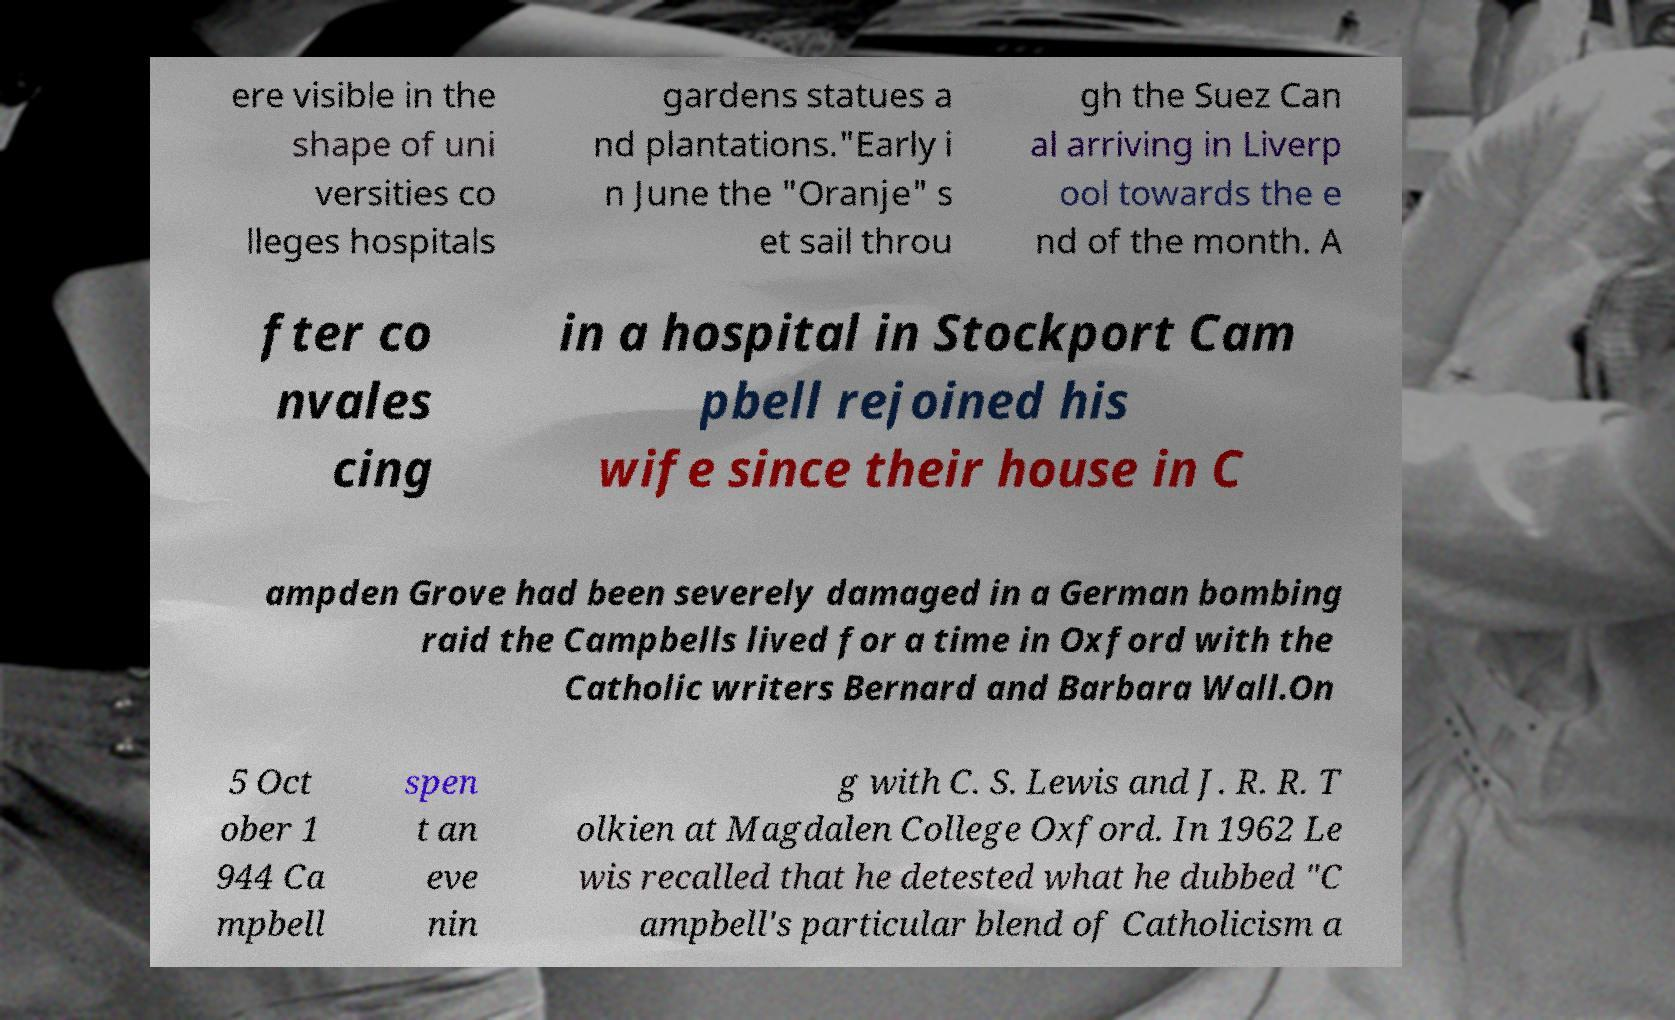Could you assist in decoding the text presented in this image and type it out clearly? ere visible in the shape of uni versities co lleges hospitals gardens statues a nd plantations."Early i n June the "Oranje" s et sail throu gh the Suez Can al arriving in Liverp ool towards the e nd of the month. A fter co nvales cing in a hospital in Stockport Cam pbell rejoined his wife since their house in C ampden Grove had been severely damaged in a German bombing raid the Campbells lived for a time in Oxford with the Catholic writers Bernard and Barbara Wall.On 5 Oct ober 1 944 Ca mpbell spen t an eve nin g with C. S. Lewis and J. R. R. T olkien at Magdalen College Oxford. In 1962 Le wis recalled that he detested what he dubbed "C ampbell's particular blend of Catholicism a 